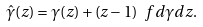Convert formula to latex. <formula><loc_0><loc_0><loc_500><loc_500>\hat { \gamma } ( z ) = \gamma ( z ) + ( z - 1 ) \ f { d \gamma } { d z } .</formula> 